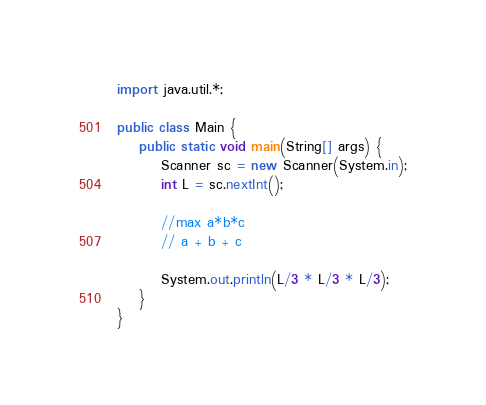<code> <loc_0><loc_0><loc_500><loc_500><_Java_>import java.util.*;

public class Main {
    public static void main(String[] args) {
        Scanner sc = new Scanner(System.in);
        int L = sc.nextInt();
        
        //max a*b*c
        // a + b + c 

        System.out.println(L/3 * L/3 * L/3);
    }
}</code> 